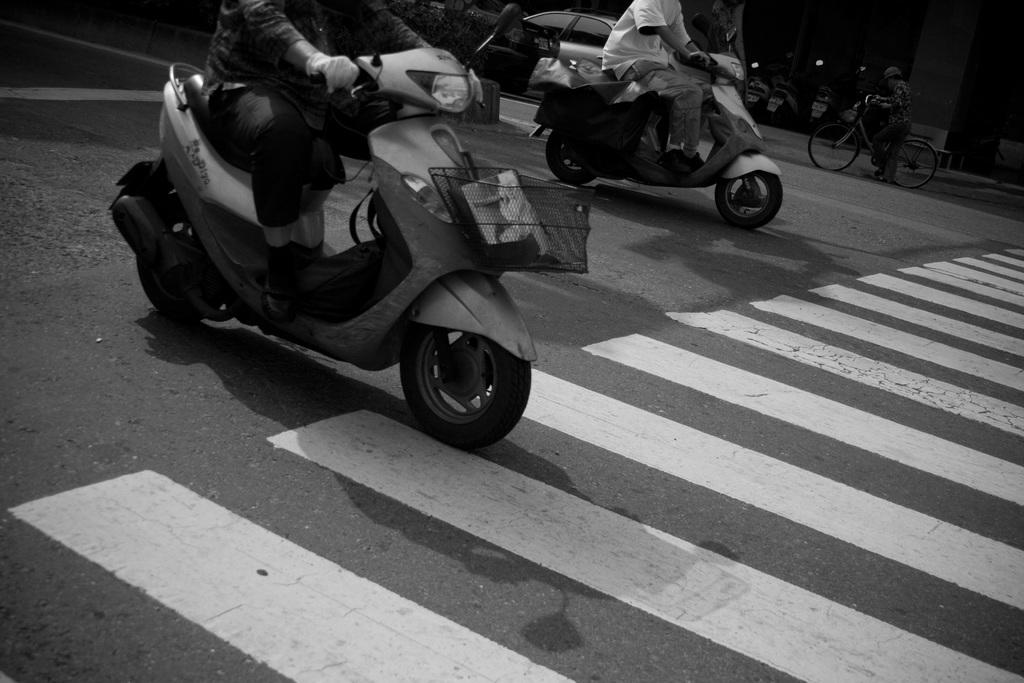How many people are in the image? There are two persons in the image. What are the two persons doing in the image? The two persons are riding a bike. What is the person on the back of the bike holding? One person is holding a bicycle. What can be seen in the background of the image? There is a road in the image. Are there any vehicles visible in the image? Yes, there is a car in the image. What type of baseball equipment can be seen in the image? There is no baseball equipment present in the image. What type of teeth can be seen in the image? There are no teeth visible in the image. 